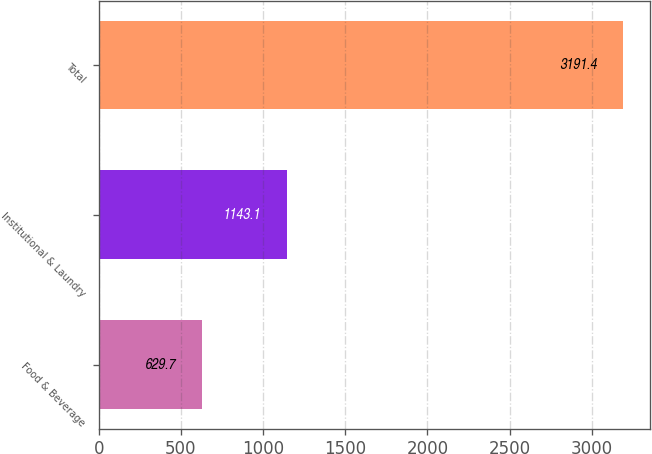Convert chart. <chart><loc_0><loc_0><loc_500><loc_500><bar_chart><fcel>Food & Beverage<fcel>Institutional & Laundry<fcel>Total<nl><fcel>629.7<fcel>1143.1<fcel>3191.4<nl></chart> 